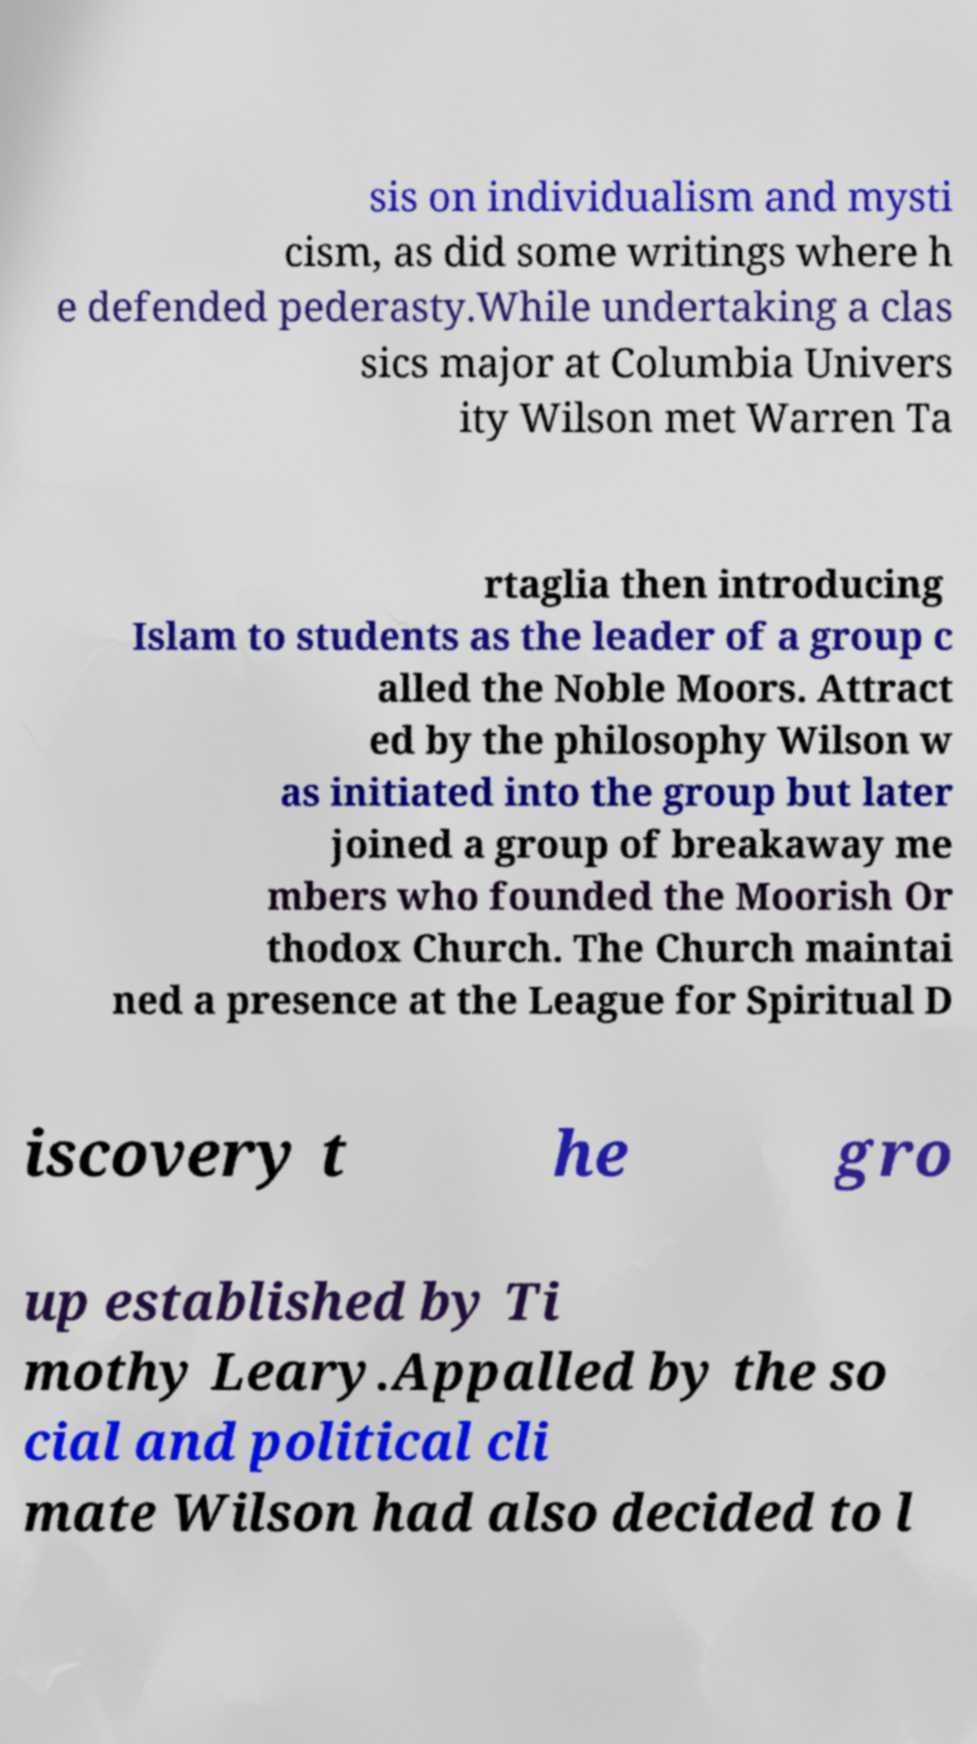Can you read and provide the text displayed in the image?This photo seems to have some interesting text. Can you extract and type it out for me? sis on individualism and mysti cism, as did some writings where h e defended pederasty.While undertaking a clas sics major at Columbia Univers ity Wilson met Warren Ta rtaglia then introducing Islam to students as the leader of a group c alled the Noble Moors. Attract ed by the philosophy Wilson w as initiated into the group but later joined a group of breakaway me mbers who founded the Moorish Or thodox Church. The Church maintai ned a presence at the League for Spiritual D iscovery t he gro up established by Ti mothy Leary.Appalled by the so cial and political cli mate Wilson had also decided to l 